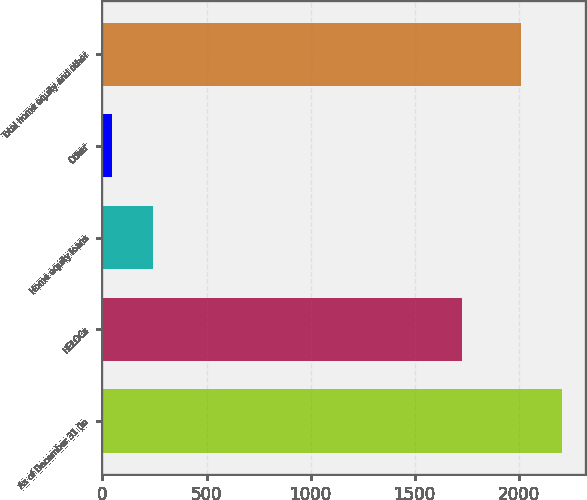Convert chart to OTSL. <chart><loc_0><loc_0><loc_500><loc_500><bar_chart><fcel>As of December 31 (in<fcel>HELOCs<fcel>Home equity loans<fcel>Other<fcel>Total home equity and other<nl><fcel>2206.59<fcel>1729.9<fcel>244.19<fcel>47.1<fcel>2009.5<nl></chart> 